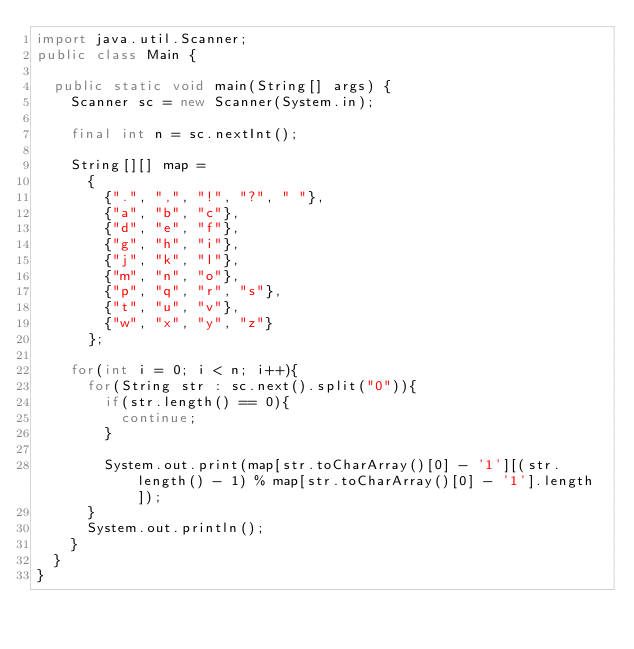<code> <loc_0><loc_0><loc_500><loc_500><_Java_>import java.util.Scanner;
public class Main {
		
	public static void main(String[] args) {
		Scanner sc = new Scanner(System.in);
		
		final int n = sc.nextInt();
		
		String[][] map = 
			{
				{".", ",", "!", "?", " "},
				{"a", "b", "c"},
				{"d", "e", "f"},
				{"g", "h", "i"},
				{"j", "k", "l"},
				{"m", "n", "o"},
				{"p", "q", "r", "s"},
				{"t", "u", "v"},
				{"w", "x", "y", "z"}
			};
		
		for(int i = 0; i < n; i++){
			for(String str : sc.next().split("0")){
				if(str.length() == 0){
					continue;
				}
				
				System.out.print(map[str.toCharArray()[0] - '1'][(str.length() - 1) % map[str.toCharArray()[0] - '1'].length]);
			}
			System.out.println();
		}
	}
}</code> 